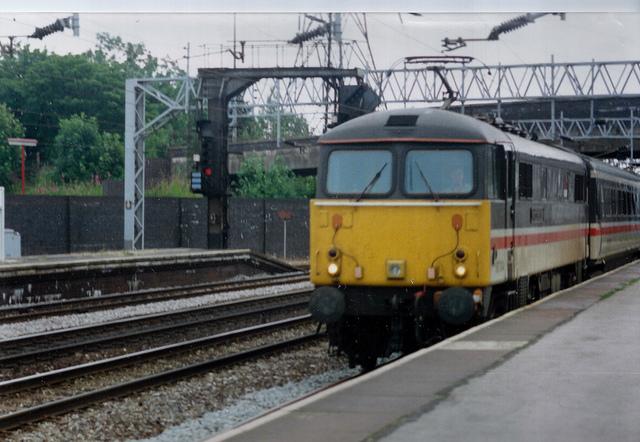What color is the train?
Quick response, please. Yellow. What color are the doors on the train?
Answer briefly. Black. What is the train on?
Be succinct. Tracks. Is the front of the train yellow?
Be succinct. Yes. Is the conductor wearing a hat?
Write a very short answer. No. How many cars?
Answer briefly. 0. 